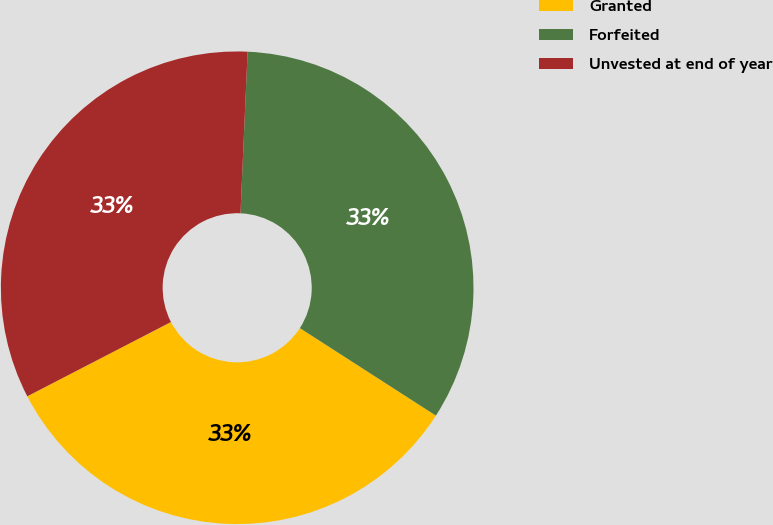<chart> <loc_0><loc_0><loc_500><loc_500><pie_chart><fcel>Granted<fcel>Forfeited<fcel>Unvested at end of year<nl><fcel>33.31%<fcel>33.4%<fcel>33.3%<nl></chart> 